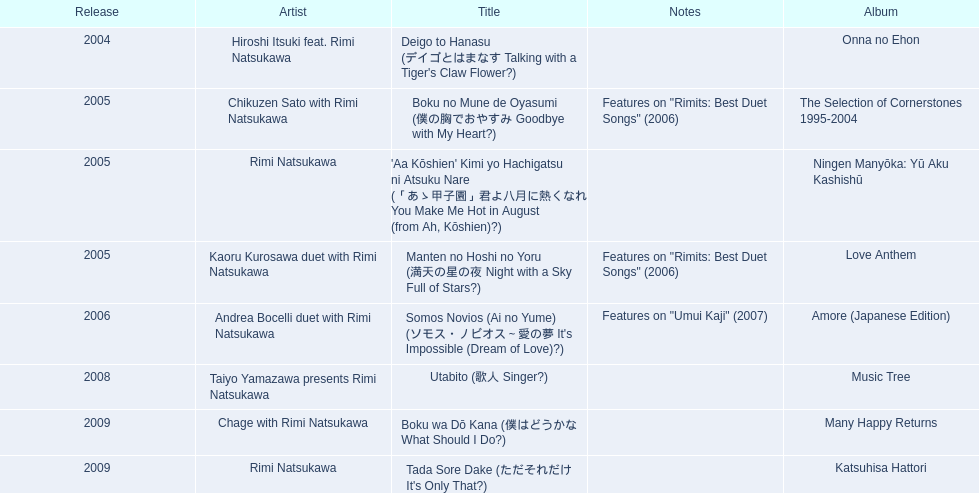What are the notes for sky full of stars? Features on "Rimits: Best Duet Songs" (2006). What other song features this same note? Boku no Mune de Oyasumi (僕の胸でおやすみ Goodbye with My Heart?). 